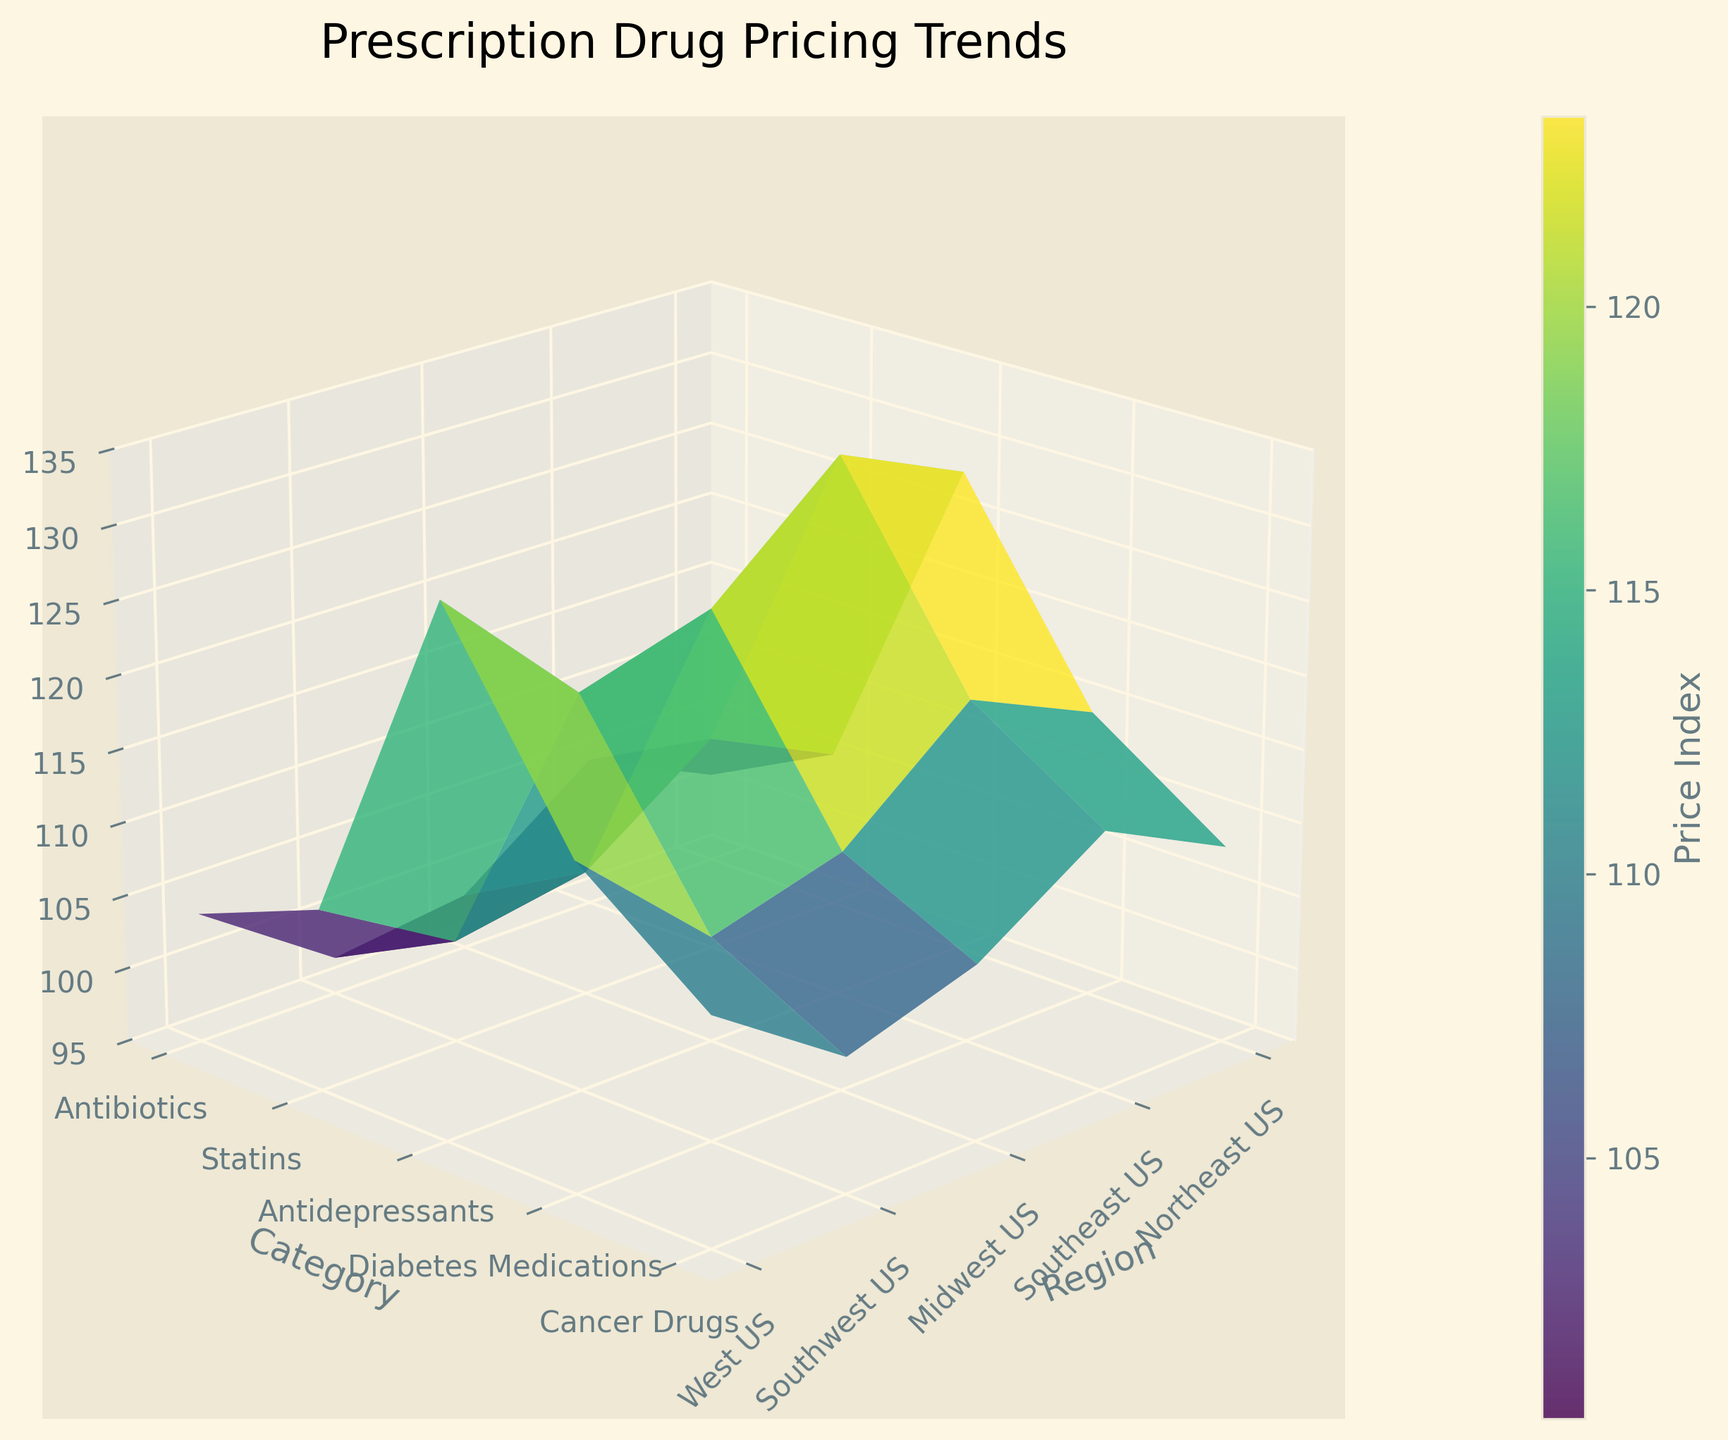What is the title of the plot? The title of the plot is usually displayed at the top in a larger font and summarizes the main topic of the data being visualized.
Answer: Prescription Drug Pricing Trends Which regions are included on the x-axis? The x-axis represents different geographic regions. The labels are displayed along this axis. By checking the labels, we can identify the regions.
Answer: Northeast US, Southeast US, Midwest US, Southwest US, West US Which pharmaceutical category has the highest price index in the Northeast US? To identify the category with the highest price index, observe the heights of the 3D surface plot over the Northeast US region. The highest peak represents the category with the highest index.
Answer: Cancer Drugs What are the z-axis limits in the plot? The z-axis limits are usually mentioned beside the axis in the plot. These limits constrain the range of values displayed for the price index.
Answer: 95 to 135 Which pharmaceutical category shows the lowest price index in the Southwest US? By inspecting the Southwest US region and locating the lowest point on the 3D surface, the corresponding category can be identified as having the lowest price index.
Answer: Antibiotics How does the price index for Statins in the West US compare to that in the Southeast US? Compare the heights of the 3D surface for Statins between the West US and Southeast US regions. The relative height will indicate which has a higher price index.
Answer: West US is higher Which two categories display a similar price index pattern across all regions? By examining the 3D surface plot and looking for similarly shaped surfaces (similar height variations) across regions for two categories, we can identify patterns.
Answer: Antibiotics and Antidepressants Is there any category that consistently shows a higher price index in the Northeast US compared to other regions? Analyze the height of the surface in the Northeast US across all categories and compare it to other regions to find any consistently higher values.
Answer: Cancer Drugs What are the peak price index values for Diabetes Medications in the Northeast US and West US? Locate the highest points for Diabetes Medications in the Northeast US and West US regions on the 3D surface plot, and note the values from the z-axis.
Answer: 118.4 and 116.9 Which category and region combination shows the lowest price index across all the data? Inspect all points of the 3D surface to find the lowest height and identify the corresponding category and region.
Answer: Antibiotics in Southwest US What trend can be observed for Cancer Drugs across different regions? By examining the 3D surface plot for Cancer Drugs across all regions, notice the height changes and overall pattern.
Answer: Highest in Northeast US, generally high across all regions 